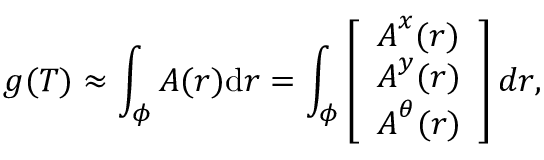Convert formula to latex. <formula><loc_0><loc_0><loc_500><loc_500>g ( T ) \approx \int _ { \phi } { A ( r ) d r } = \int _ { \phi } \left [ \begin{array} { l } { A ^ { x } ( r ) } \\ { A ^ { y } ( r ) } \\ { A ^ { \theta } ( r ) } \end{array} \right ] d r ,</formula> 